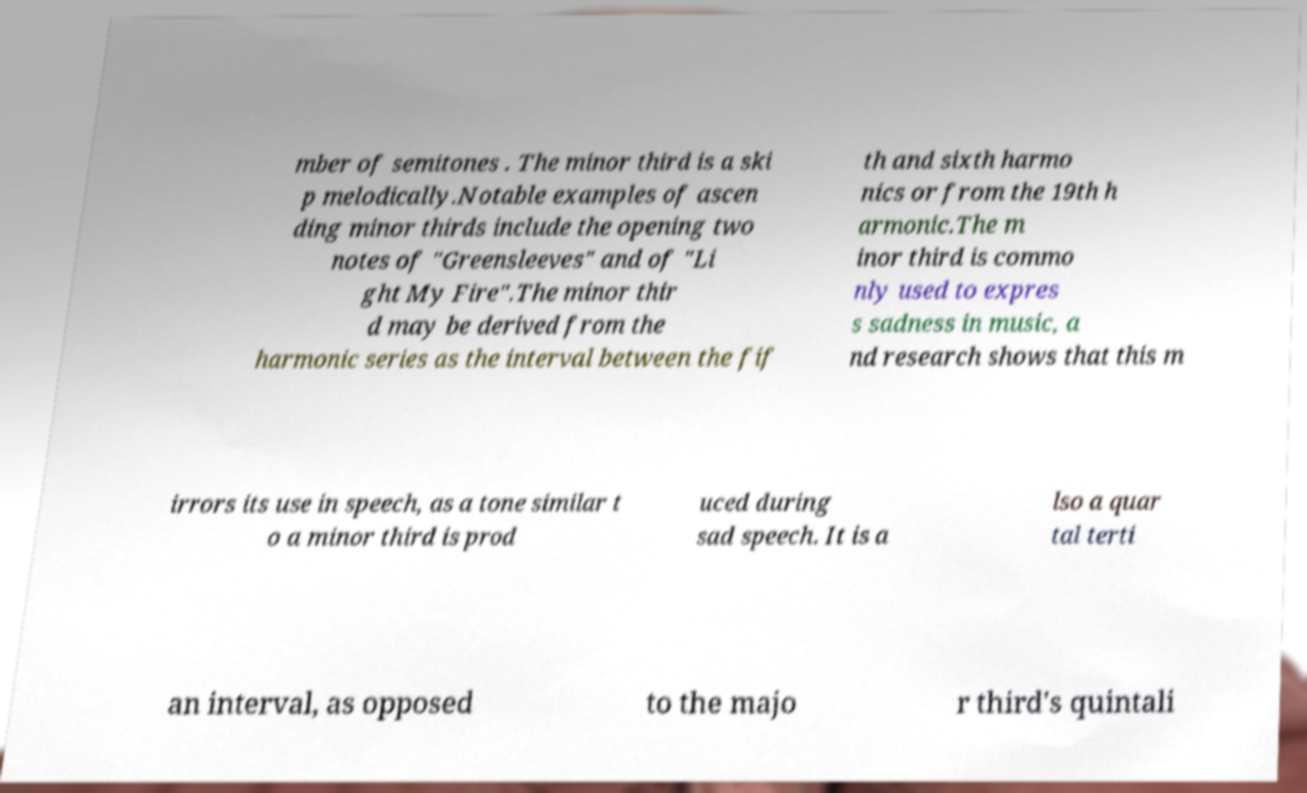What messages or text are displayed in this image? I need them in a readable, typed format. mber of semitones . The minor third is a ski p melodically.Notable examples of ascen ding minor thirds include the opening two notes of "Greensleeves" and of "Li ght My Fire".The minor thir d may be derived from the harmonic series as the interval between the fif th and sixth harmo nics or from the 19th h armonic.The m inor third is commo nly used to expres s sadness in music, a nd research shows that this m irrors its use in speech, as a tone similar t o a minor third is prod uced during sad speech. It is a lso a quar tal terti an interval, as opposed to the majo r third's quintali 